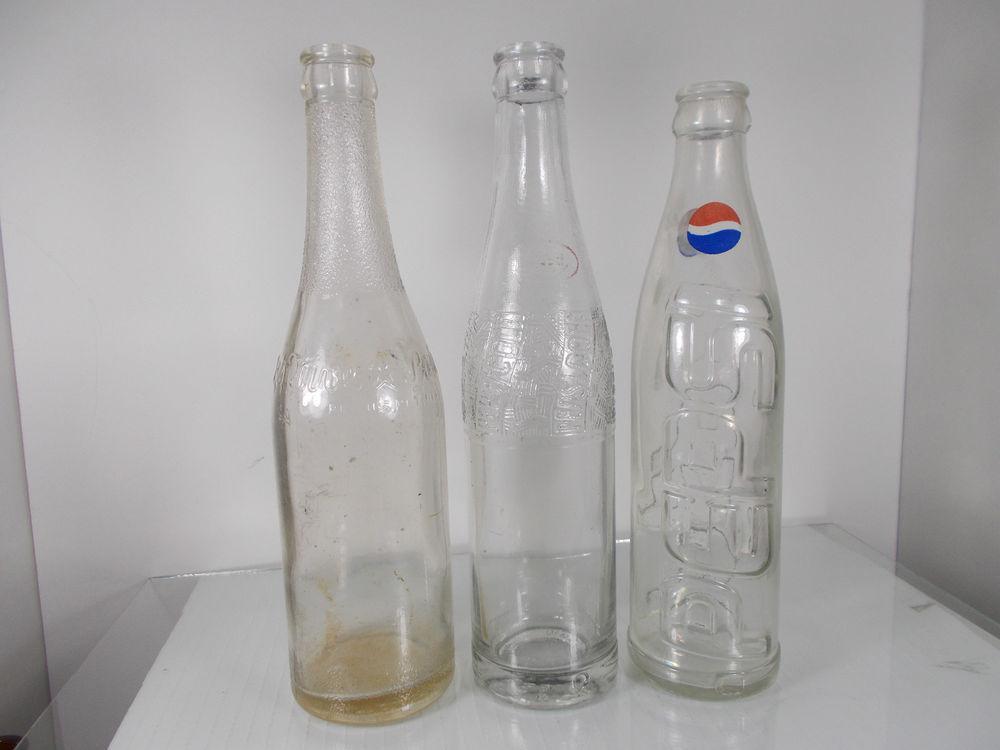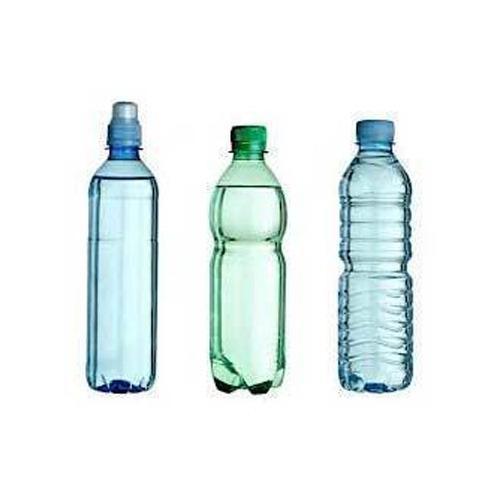The first image is the image on the left, the second image is the image on the right. Given the left and right images, does the statement "In one image all the bottles are made of plastic." hold true? Answer yes or no. Yes. The first image is the image on the left, the second image is the image on the right. Given the left and right images, does the statement "There are exactly six bottles." hold true? Answer yes or no. Yes. 